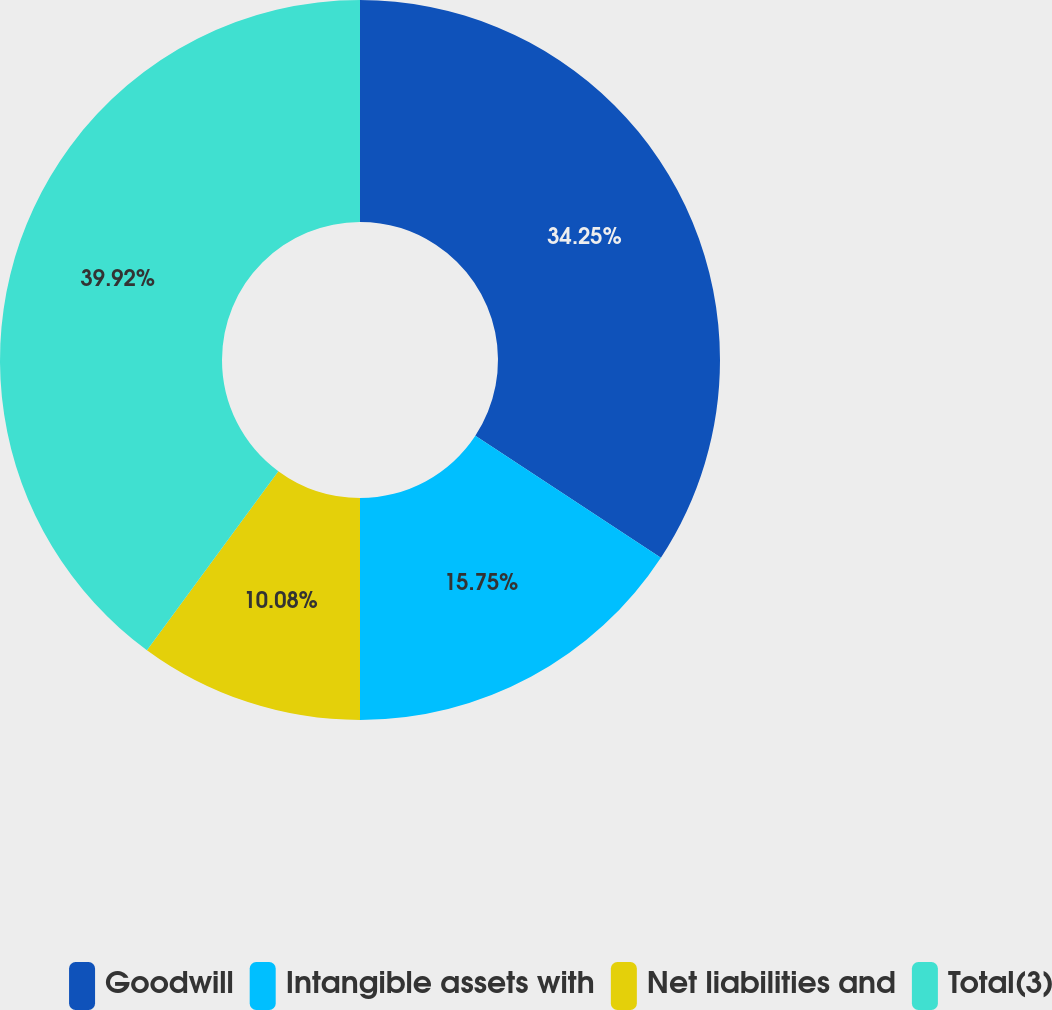Convert chart. <chart><loc_0><loc_0><loc_500><loc_500><pie_chart><fcel>Goodwill<fcel>Intangible assets with<fcel>Net liabilities and<fcel>Total(3)<nl><fcel>34.25%<fcel>15.75%<fcel>10.08%<fcel>39.92%<nl></chart> 